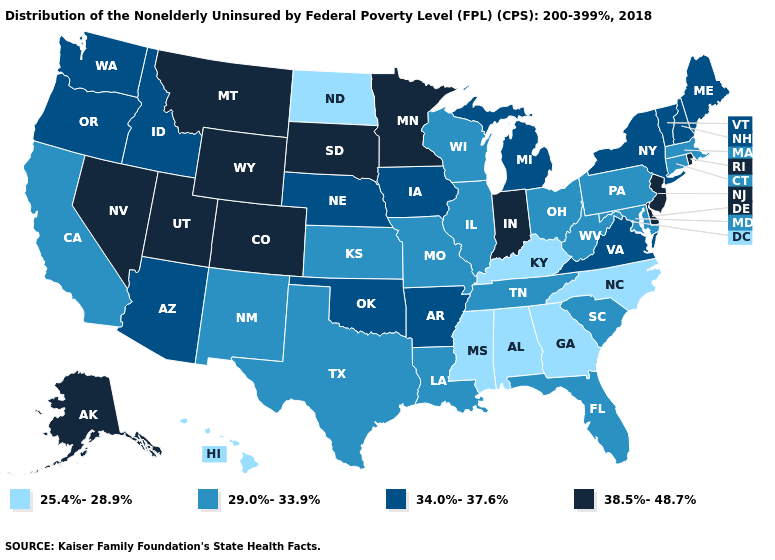What is the highest value in states that border West Virginia?
Answer briefly. 34.0%-37.6%. Does Minnesota have the same value as Illinois?
Concise answer only. No. What is the highest value in the USA?
Quick response, please. 38.5%-48.7%. What is the value of Arkansas?
Keep it brief. 34.0%-37.6%. Name the states that have a value in the range 29.0%-33.9%?
Short answer required. California, Connecticut, Florida, Illinois, Kansas, Louisiana, Maryland, Massachusetts, Missouri, New Mexico, Ohio, Pennsylvania, South Carolina, Tennessee, Texas, West Virginia, Wisconsin. What is the value of Texas?
Short answer required. 29.0%-33.9%. What is the lowest value in the South?
Give a very brief answer. 25.4%-28.9%. What is the value of Delaware?
Short answer required. 38.5%-48.7%. Which states hav the highest value in the MidWest?
Quick response, please. Indiana, Minnesota, South Dakota. Among the states that border Arizona , which have the lowest value?
Answer briefly. California, New Mexico. Does Montana have the highest value in the West?
Quick response, please. Yes. How many symbols are there in the legend?
Write a very short answer. 4. Does New York have a lower value than Indiana?
Give a very brief answer. Yes. What is the value of Connecticut?
Quick response, please. 29.0%-33.9%. Does Rhode Island have the highest value in the USA?
Write a very short answer. Yes. 